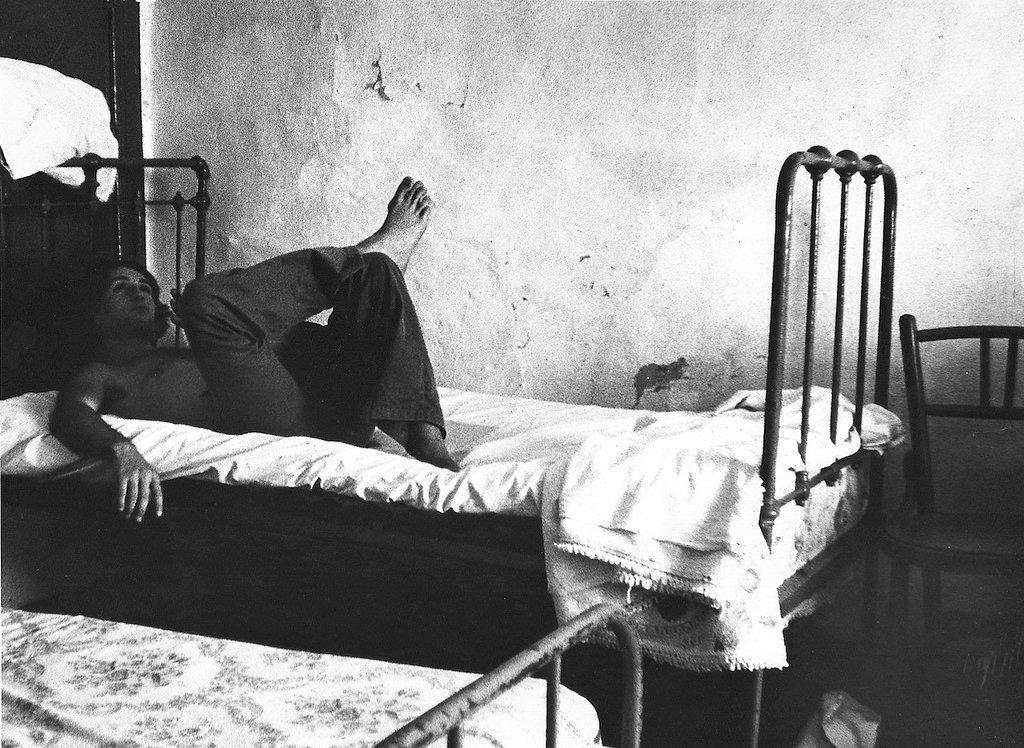What type of furniture is present in the image? There are beds and a chair in the image. What is the person in the image doing? There is a person lying on a bed in the image. What can be seen in the background of the image? There is a wall in the background of the image. What is the color scheme of the image? The image is black and white. Where is the doll sitting on the stage in the image? There is no doll or stage present in the image. What type of food is being served in the lunchroom in the image? There is no lunchroom or food present in the image. 